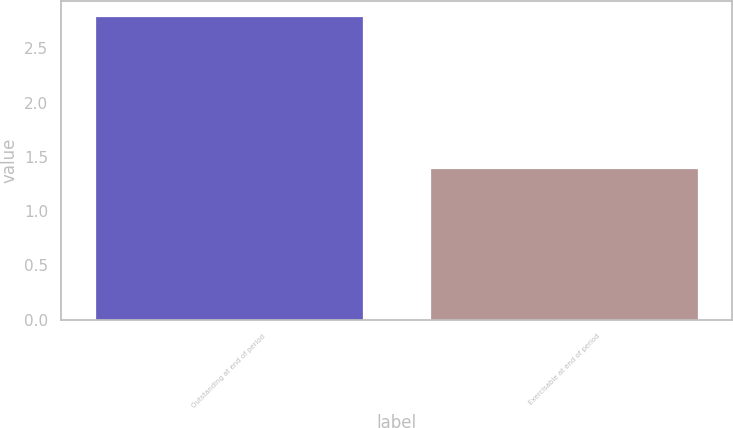<chart> <loc_0><loc_0><loc_500><loc_500><bar_chart><fcel>Outstanding at end of period<fcel>Exercisable at end of period<nl><fcel>2.8<fcel>1.4<nl></chart> 